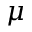<formula> <loc_0><loc_0><loc_500><loc_500>\mu</formula> 